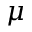<formula> <loc_0><loc_0><loc_500><loc_500>\mu</formula> 